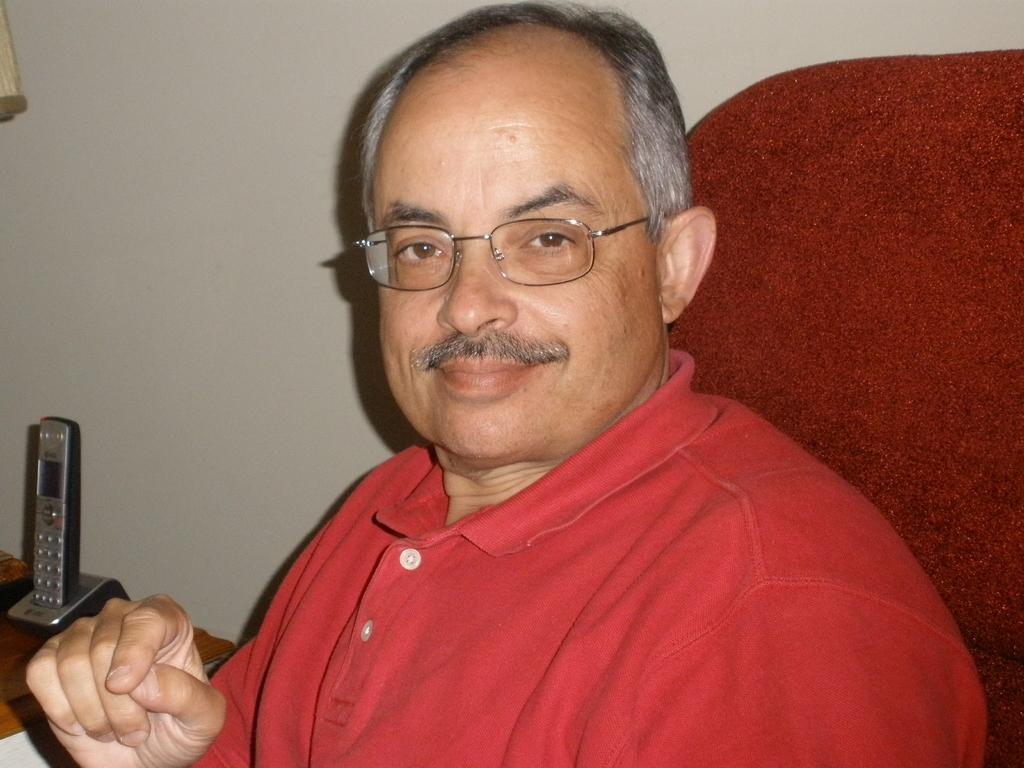What is the person in the image doing? The person is sitting on a chair in the image. What can be seen behind the person? There is a wall in the image. What object is on the table in the image? There is a phone on a table in the image. Can you describe the object at the left side of the image? Unfortunately, the provided facts do not give enough information to describe the object at the left side of the image. What type of bag is the woman carrying in the image? There is no woman or bag present in the image. 